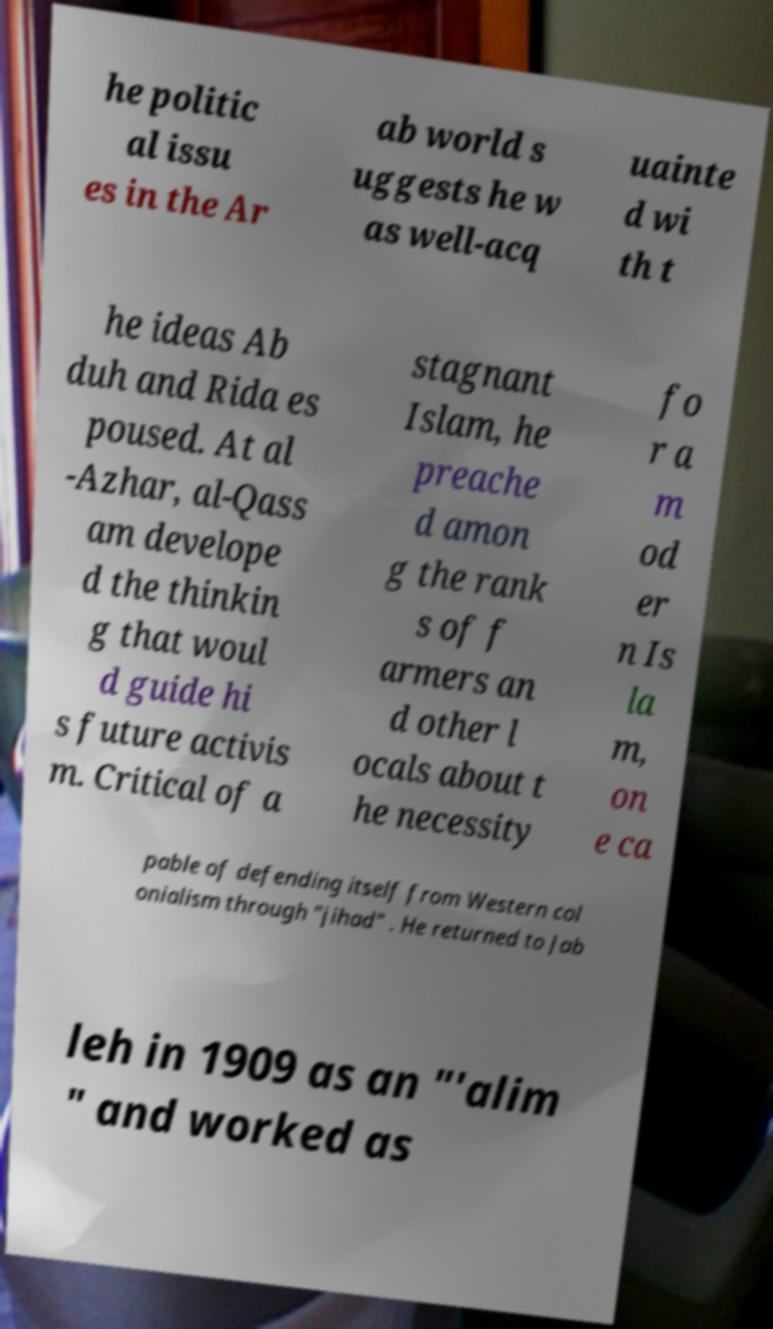Please read and relay the text visible in this image. What does it say? he politic al issu es in the Ar ab world s uggests he w as well-acq uainte d wi th t he ideas Ab duh and Rida es poused. At al -Azhar, al-Qass am develope d the thinkin g that woul d guide hi s future activis m. Critical of a stagnant Islam, he preache d amon g the rank s of f armers an d other l ocals about t he necessity fo r a m od er n Is la m, on e ca pable of defending itself from Western col onialism through "jihad" . He returned to Jab leh in 1909 as an "′alim " and worked as 